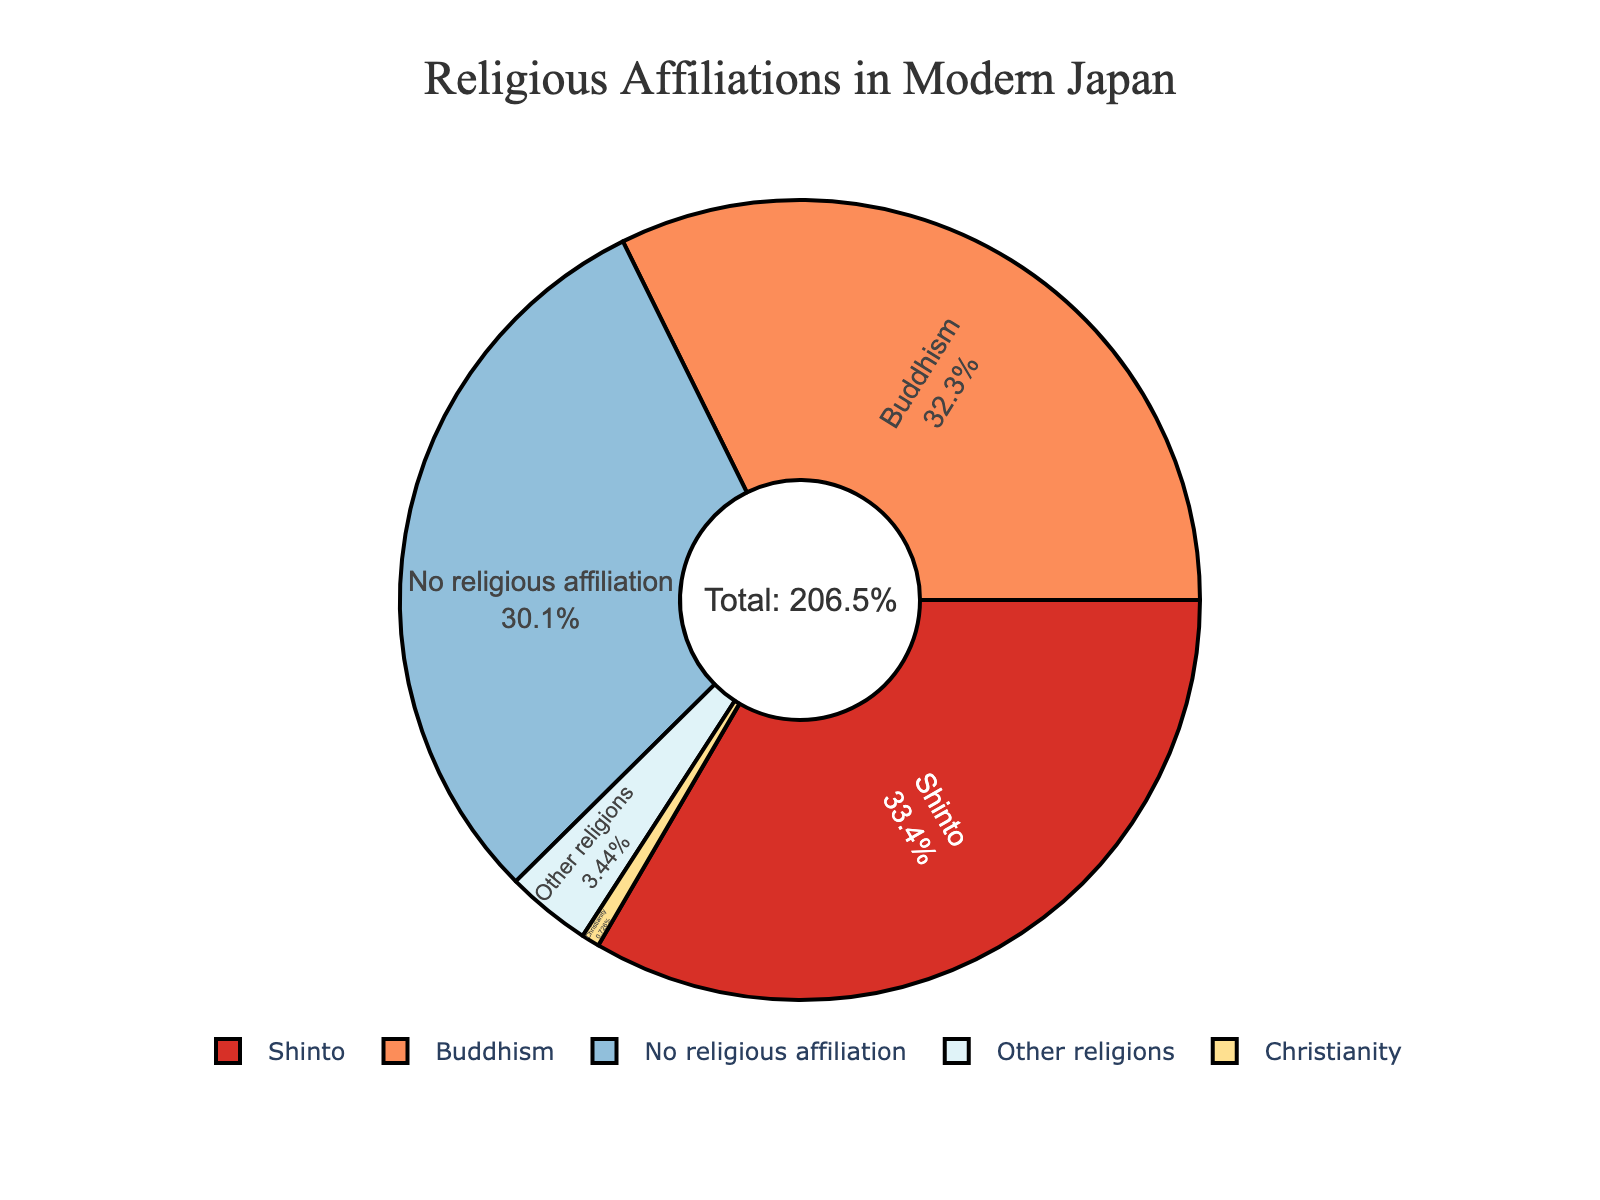What percentage of people in modern Japan identify with Shinto and Buddhism combined? To find the combined percentage of people identifying with Shinto and Buddhism, add their individual percentages: 69.0% (Shinto) + 66.7% (Buddhism) = 135.7%
Answer: 135.7% Which religious group has the smallest percentage of followers in modern Japan? The smallest percentage value on the pie chart is 1.5%, which corresponds to Christianity.
Answer: Christianity How does the percentage of people with no religious affiliation compare to those practicing Buddhism? The pie chart shows that the percentage of people with no religious affiliation is 62.2%, while the percentage of Buddhists is 66.7%. Comparing 62.2% and 66.7%, 62.2% is less than 66.7%.
Answer: Less What is the percentage difference between people who practice Christianity and those who follow other religions? To find the difference, subtract the percentage of Christians from the percentage of people who follow other religions: 7.1% (Other religions) - 1.5% (Christianity) = 5.6%.
Answer: 5.6% Which religious group has a pie chart segment represented in the darkest color? The segment for Shinto is shown in the darkest color on the pie chart. The colors are usually labeled distinctly, and the darkest one corresponds to Shinto.
Answer: Shinto Does the total percentage add up to 100%? Adding all the percentages: 69.0% (Shinto) + 66.7% (Buddhism) + 1.5% (Christianity) + 7.1% (Other religions) + 62.2% (No religious affiliation) = 206.5%. This shows that people may identify with multiple religions, and the total exceeds 100%.
Answer: No What percentage of the population identifies with at least one religion (Shinto, Buddhism, Christianity, or other religions)? To find this, add the percentages of Shinto, Buddhism, Christianity, and other religions: 69.0% + 66.7% + 1.5% + 7.1% = 144.3%. This total indicates that some individuals may identify with multiple religions.
Answer: 144.3% How many religious groups are displayed on the pie chart, excluding the 'No religious affiliation' category? The pie chart includes Shinto, Buddhism, Christianity, and other religions. There are 4 groups excluding the 'No religious affiliation' category.
Answer: 4 Which two religious groups have the closest percentages? By examining the percentages, Shinto (69.0%) and Buddhism (66.7%) have the closest percentages. The difference between them is 69.0% - 66.7% = 2.3%.
Answer: Shinto and Buddhism Is there any religious group that has a percentage higher than the 'No religious affiliation' category? The 'No religious affiliation' category shows 62.2%. Both Shinto (69.0%) and Buddhism (66.7%) have higher percentages than this.
Answer: Yes 